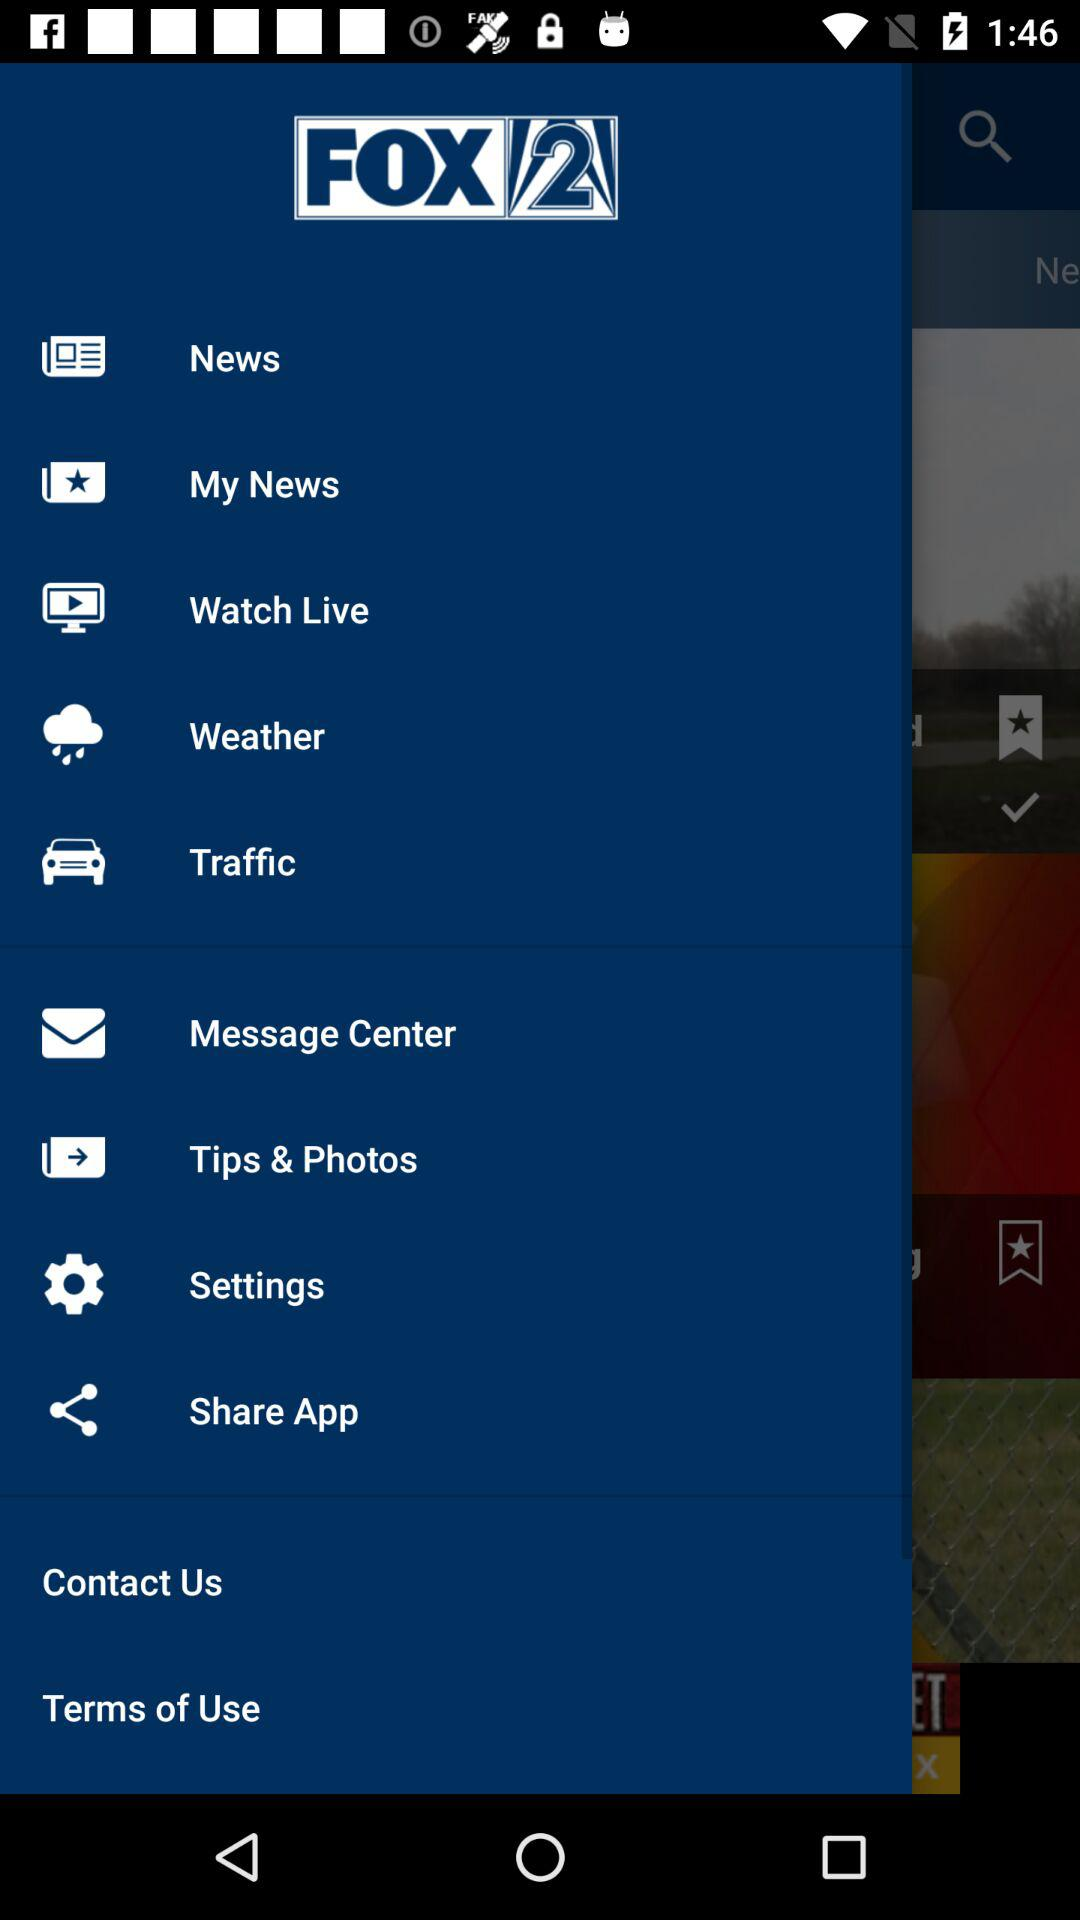What is the name of the application? The name of the application is "FOX 2". 